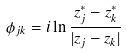<formula> <loc_0><loc_0><loc_500><loc_500>\phi _ { j k } = i \ln \frac { z _ { j } ^ { * } - z _ { k } ^ { * } } { | z _ { j } - z _ { k } | }</formula> 